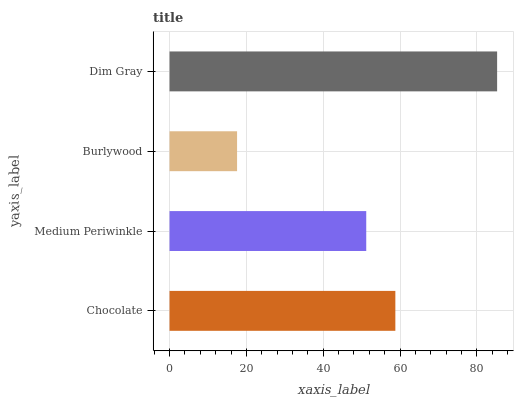Is Burlywood the minimum?
Answer yes or no. Yes. Is Dim Gray the maximum?
Answer yes or no. Yes. Is Medium Periwinkle the minimum?
Answer yes or no. No. Is Medium Periwinkle the maximum?
Answer yes or no. No. Is Chocolate greater than Medium Periwinkle?
Answer yes or no. Yes. Is Medium Periwinkle less than Chocolate?
Answer yes or no. Yes. Is Medium Periwinkle greater than Chocolate?
Answer yes or no. No. Is Chocolate less than Medium Periwinkle?
Answer yes or no. No. Is Chocolate the high median?
Answer yes or no. Yes. Is Medium Periwinkle the low median?
Answer yes or no. Yes. Is Dim Gray the high median?
Answer yes or no. No. Is Burlywood the low median?
Answer yes or no. No. 